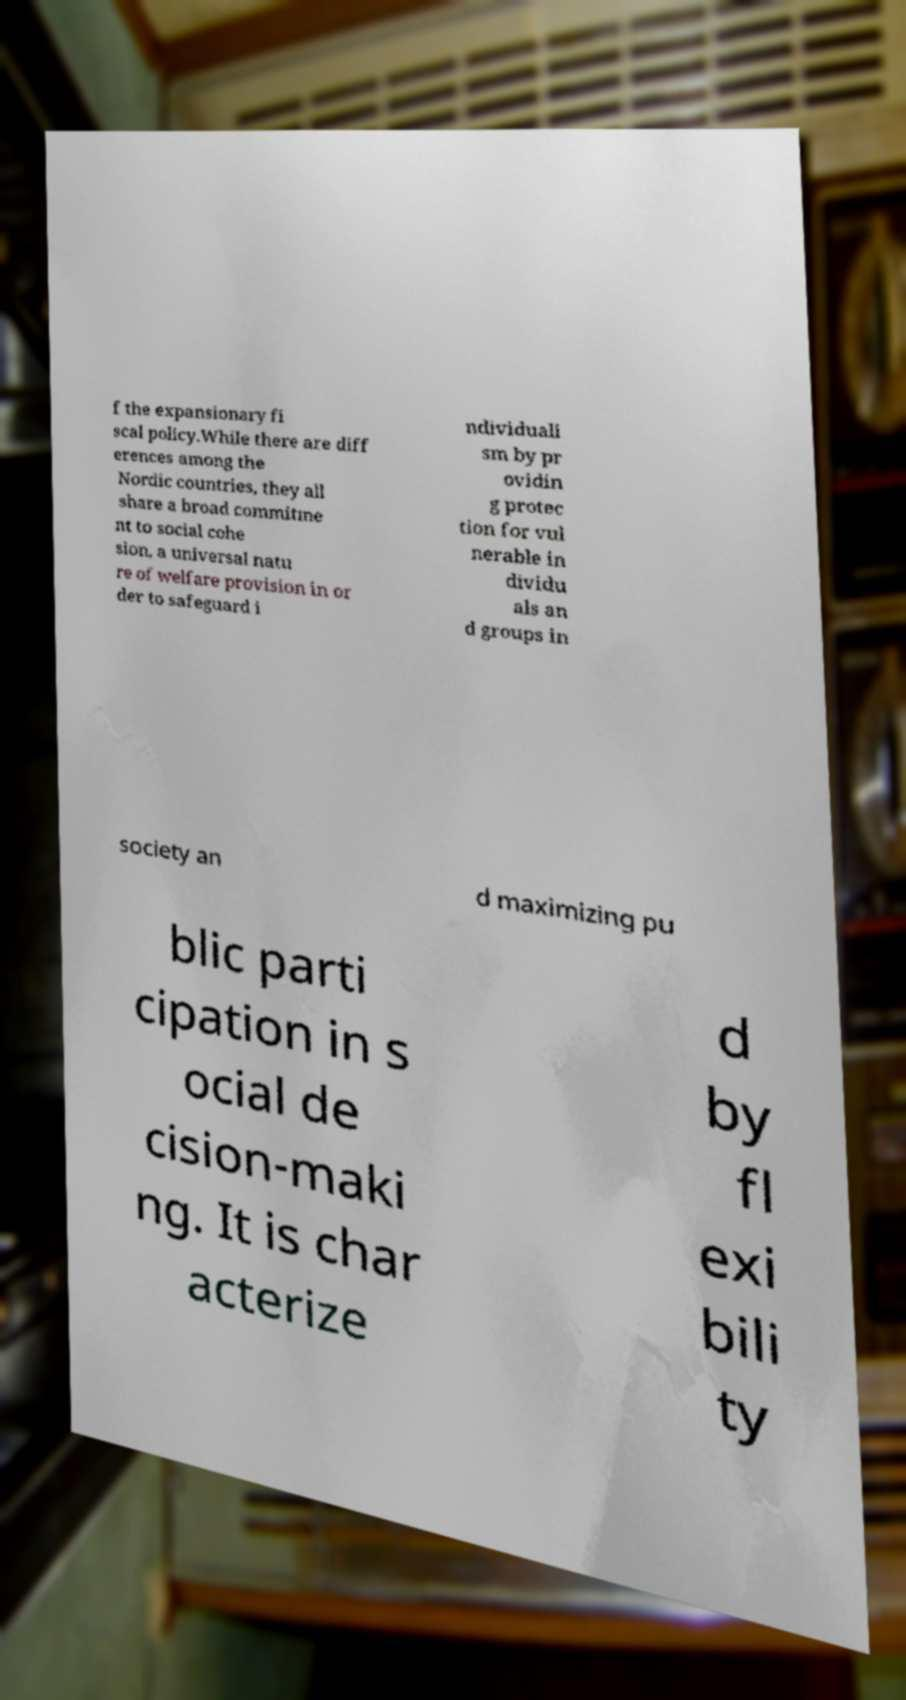Please identify and transcribe the text found in this image. f the expansionary fi scal policy.While there are diff erences among the Nordic countries, they all share a broad commitme nt to social cohe sion, a universal natu re of welfare provision in or der to safeguard i ndividuali sm by pr ovidin g protec tion for vul nerable in dividu als an d groups in society an d maximizing pu blic parti cipation in s ocial de cision-maki ng. It is char acterize d by fl exi bili ty 